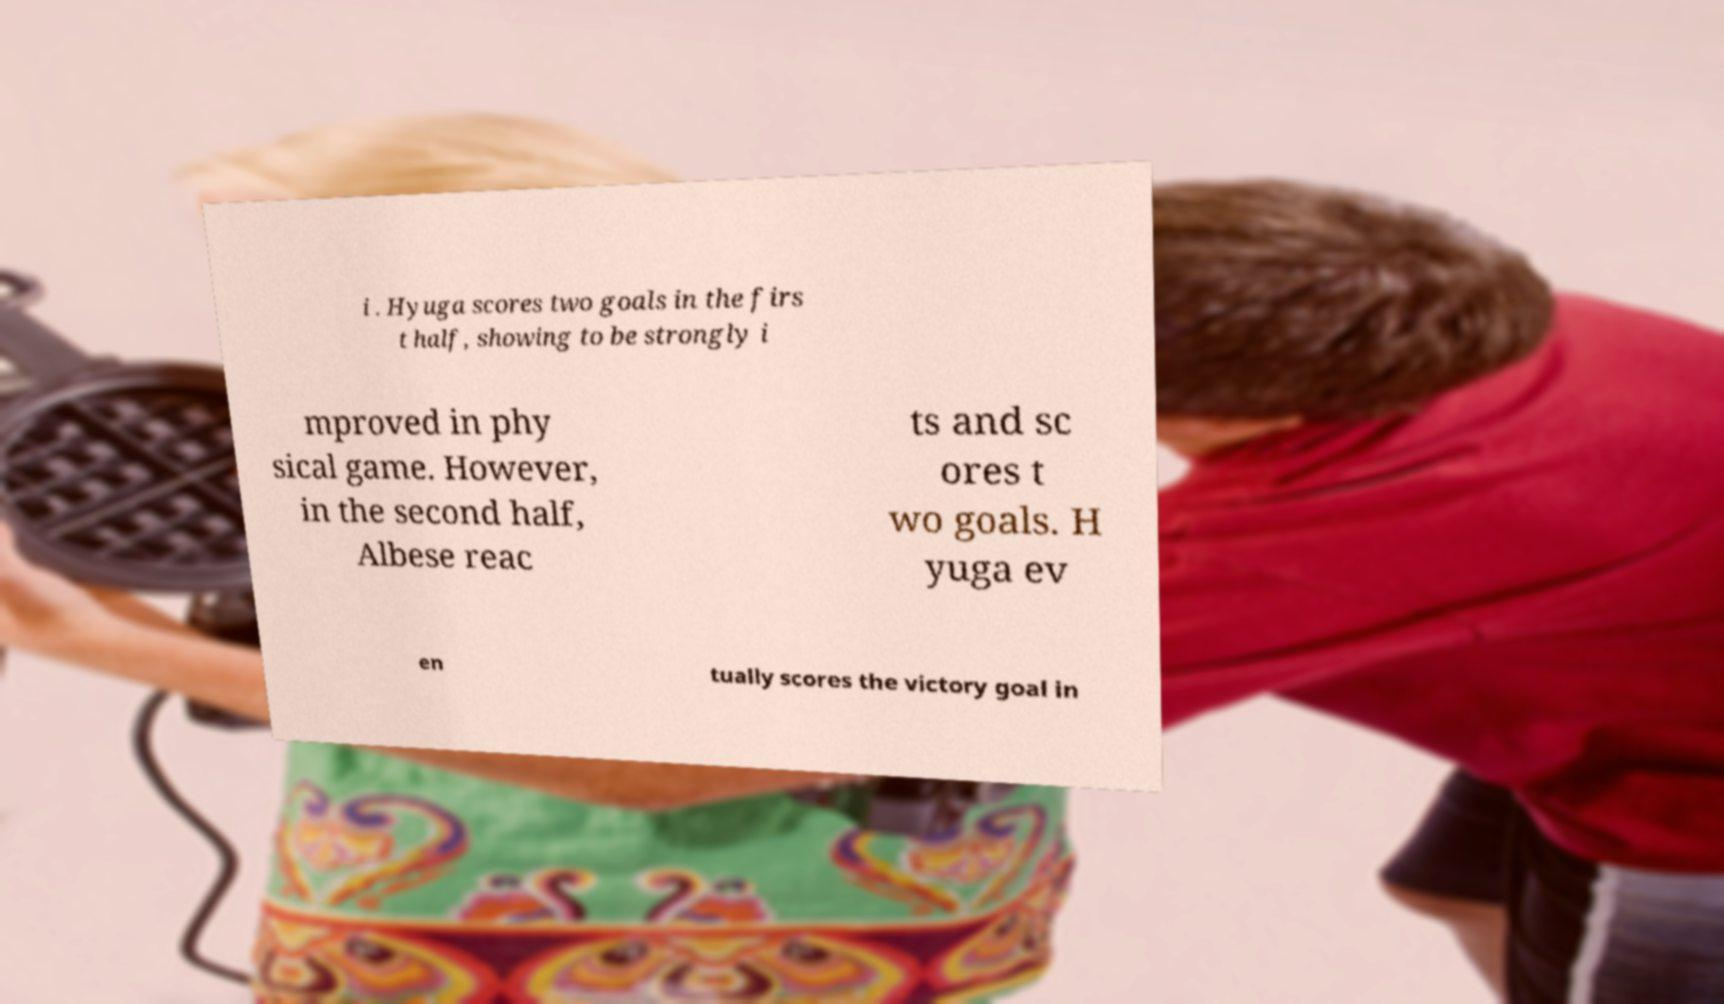Please identify and transcribe the text found in this image. i . Hyuga scores two goals in the firs t half, showing to be strongly i mproved in phy sical game. However, in the second half, Albese reac ts and sc ores t wo goals. H yuga ev en tually scores the victory goal in 